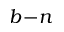Convert formula to latex. <formula><loc_0><loc_0><loc_500><loc_500>b \, - \, n</formula> 